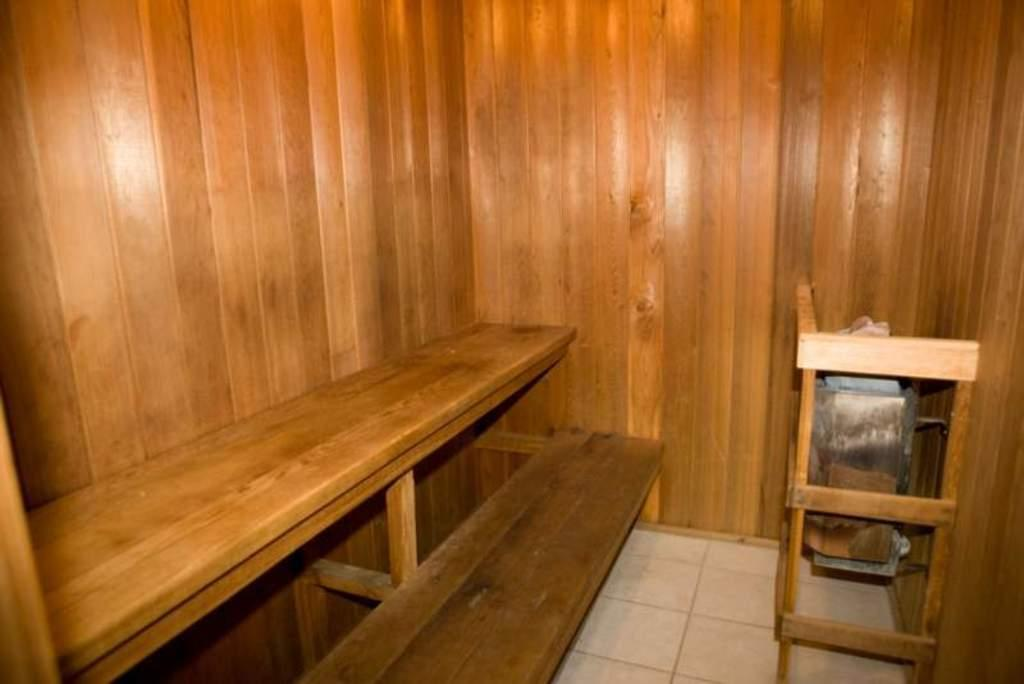What material is used to construct the room in the image? The room is made up of wood. What is the primary material used for the walls in the room? The walls are made of wood. Can you describe any furniture pieces in the room? There is a bench made of wood and a chair made of wood in the room. What type of flooring is present in the room? The floor has white tiles. What type of advice is given by the suit in the room? There is no suit or advice present in the room; the image only features wooden furniture and white-tiled flooring. 